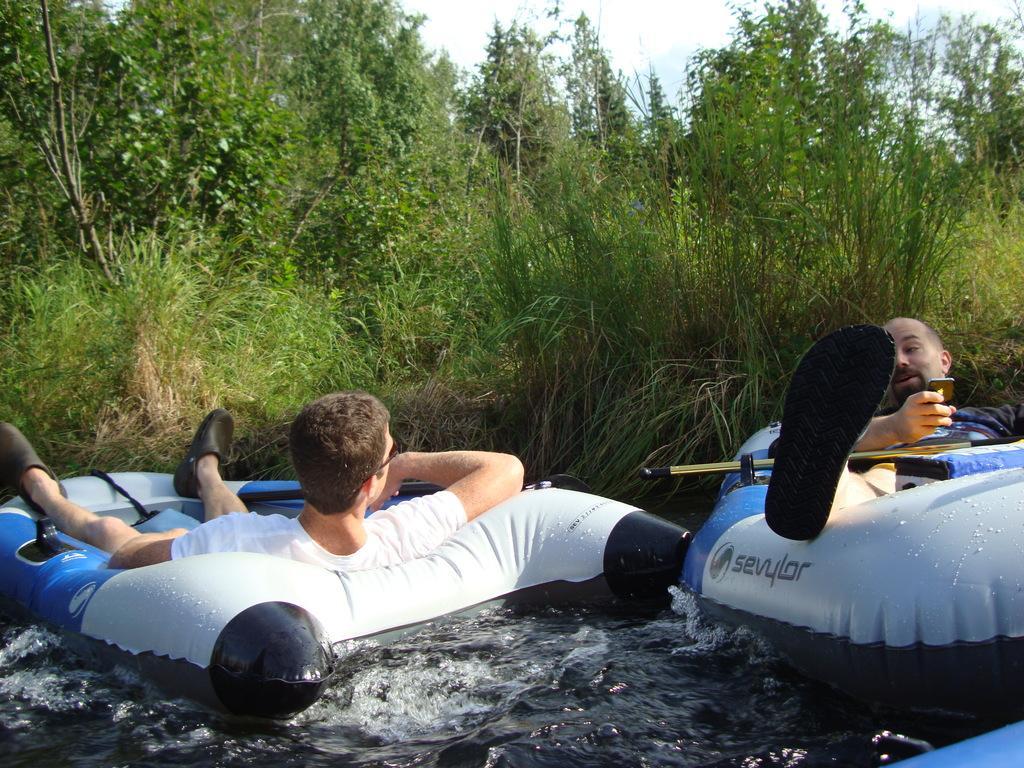Could you give a brief overview of what you see in this image? In this image we can see water balloons, persons, water, trees, plants, sky and clouds. 